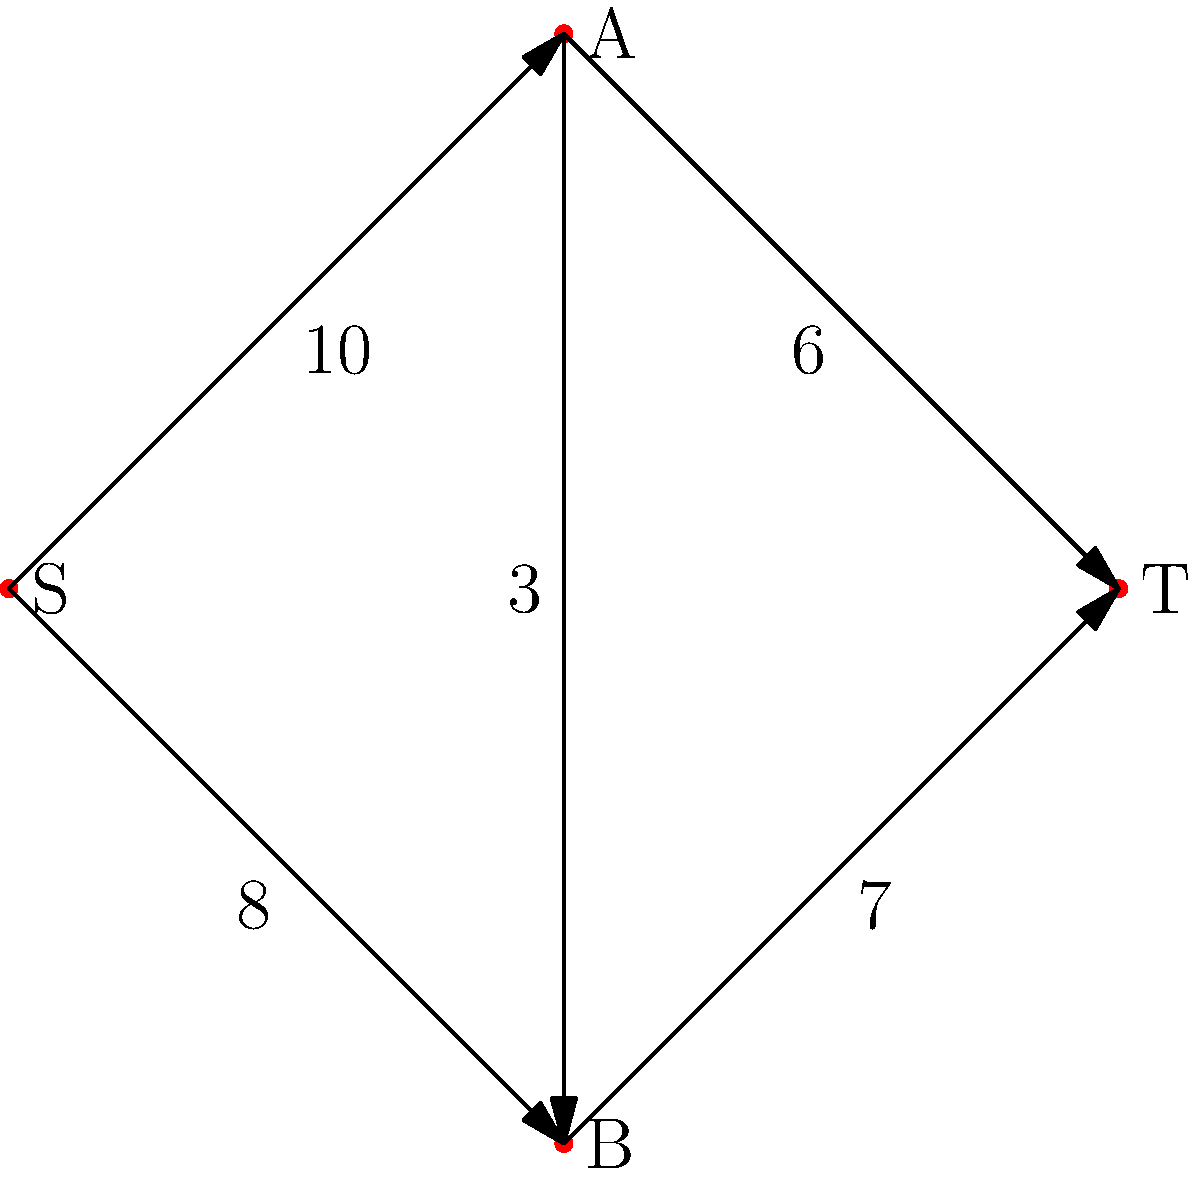In a legal resource allocation network, nodes represent different legal teams, and edges represent the maximum number of cases that can be transferred between teams. Given the network flow graph above, where S is the source (central resource pool) and T is the sink (final case distribution), what is the maximum flow of cases from S to T? To solve this maximum flow problem, we'll use the Ford-Fulkerson algorithm:

1. Initialize flow to 0.

2. Find an augmenting path from S to T:
   Path 1: S → A → T (min capacity: 6)
   Increase flow by 6. Residual graph:
   S → A: 4, A → T: 0, S → B: 8, B → T: 7, A → B: 3

3. Find another augmenting path:
   Path 2: S → B → T (min capacity: 7)
   Increase flow by 7. Residual graph:
   S → A: 4, A → T: 0, S → B: 1, B → T: 0, A → B: 3

4. Find another augmenting path:
   Path 3: S → A → B → T (min capacity: 1)
   Increase flow by 1. Residual graph:
   S → A: 3, A → T: 0, S → B: 0, B → T: 0, A → B: 2

5. No more augmenting paths exist.

The maximum flow is the sum of all flow increases:
6 + 7 + 1 = 14 cases.
Answer: 14 cases 